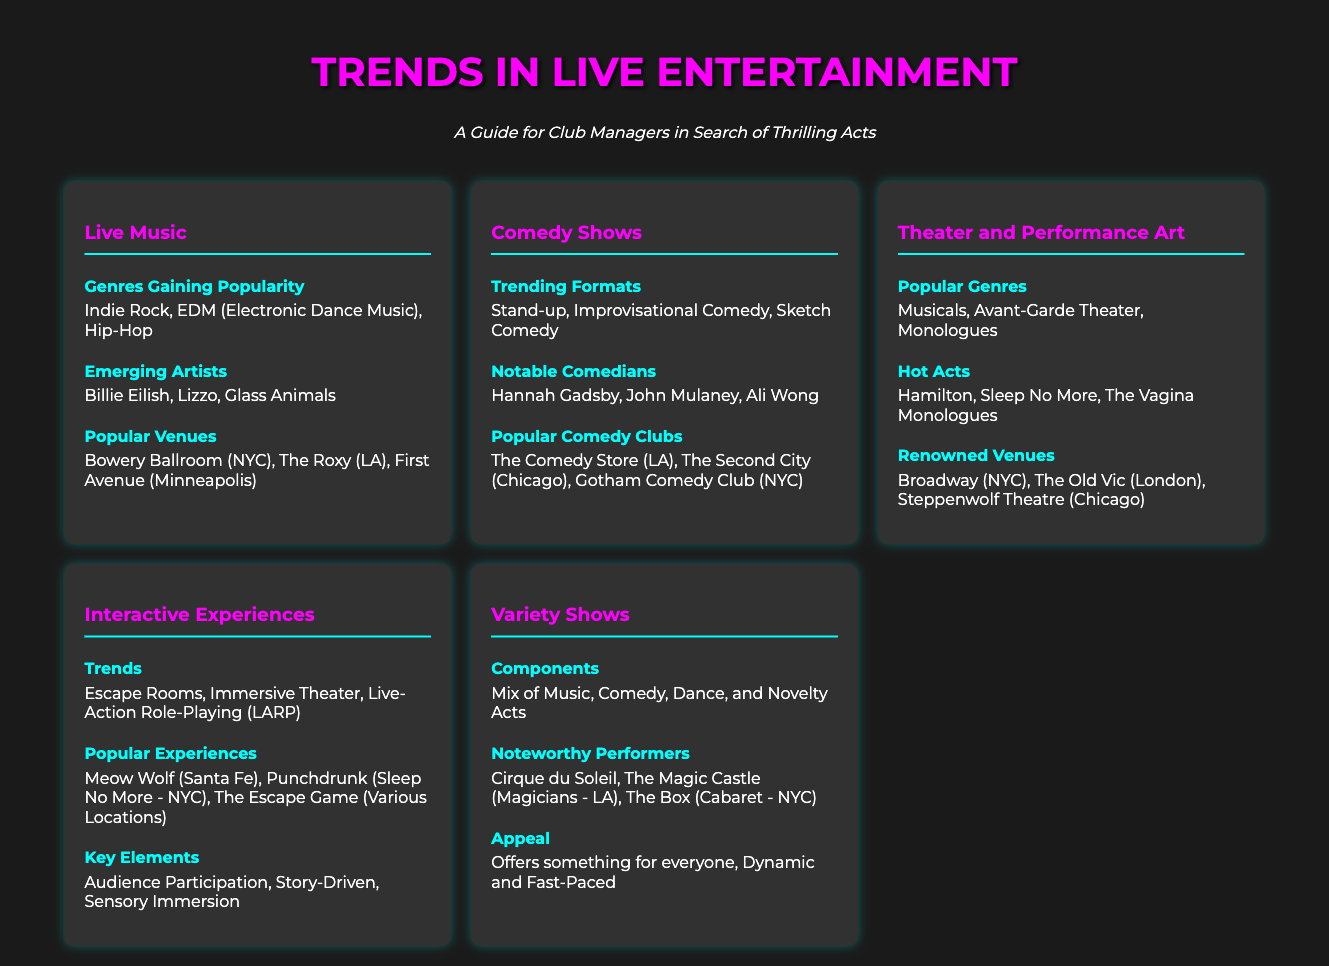what genres are gaining popularity in live music? The document lists the genres that are currently gaining popularity in live music, which include Indie Rock, EDM, and Hip-Hop.
Answer: Indie Rock, EDM, Hip-Hop who are some emerging artists in live music? The document mentions specific artists who are considered emerging talents in live music, including Billie Eilish, Lizzo, and Glass Animals.
Answer: Billie Eilish, Lizzo, Glass Animals what are the trending formats in comedy shows? The document identifies the types of comedy formats that are trending today, specifically Stand-up, Improvisational Comedy, and Sketch Comedy.
Answer: Stand-up, Improvisational Comedy, Sketch Comedy which notable comedians are mentioned? The document provides names of notable comedians currently in the spotlight, citing Hannah Gadsby, John Mulaney, and Ali Wong.
Answer: Hannah Gadsby, John Mulaney, Ali Wong which venue is renowned for its theater performances? The document lists the venues known for theater performances, and Broadway in NYC is the most prominent among them.
Answer: Broadway (NYC) what types of interactive experiences are trending? The document highlights interactive experiences gaining popularity, specifically mentioning Escape Rooms, Immersive Theater, and Live-Action Role-Playing (LARP).
Answer: Escape Rooms, Immersive Theater, Live-Action Role-Playing (LARP) what is a key element of interactive experiences? The document states that a crucial aspect of interactive experiences is audience participation, emphasizing that this enhances the experience.
Answer: Audience Participation what comprises a variety show? The document describes the components that make up a variety show, mentioning that it typically features a mix of Music, Comedy, Dance, and Novelty Acts.
Answer: Mix of Music, Comedy, Dance, and Novelty Acts how do variety shows appeal to audiences? The document explains that variety shows appeal because they offer something for everyone and are dynamic and fast-paced.
Answer: Offers something for everyone, Dynamic and Fast-Paced 